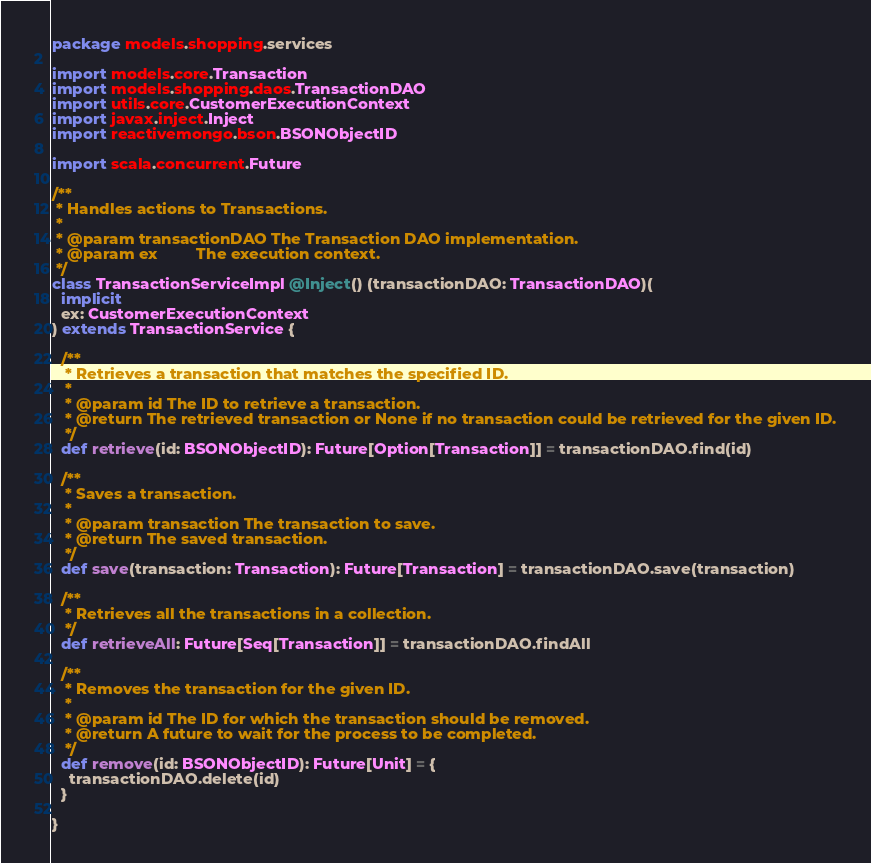<code> <loc_0><loc_0><loc_500><loc_500><_Scala_>package models.shopping.services

import models.core.Transaction
import models.shopping.daos.TransactionDAO
import utils.core.CustomerExecutionContext
import javax.inject.Inject
import reactivemongo.bson.BSONObjectID

import scala.concurrent.Future

/**
 * Handles actions to Transactions.
 *
 * @param transactionDAO The Transaction DAO implementation.
 * @param ex         The execution context.
 */
class TransactionServiceImpl @Inject() (transactionDAO: TransactionDAO)(
  implicit
  ex: CustomerExecutionContext
) extends TransactionService {

  /**
   * Retrieves a transaction that matches the specified ID.
   *
   * @param id The ID to retrieve a transaction.
   * @return The retrieved transaction or None if no transaction could be retrieved for the given ID.
   */
  def retrieve(id: BSONObjectID): Future[Option[Transaction]] = transactionDAO.find(id)

  /**
   * Saves a transaction.
   *
   * @param transaction The transaction to save.
   * @return The saved transaction.
   */
  def save(transaction: Transaction): Future[Transaction] = transactionDAO.save(transaction)

  /**
   * Retrieves all the transactions in a collection.
   */
  def retrieveAll: Future[Seq[Transaction]] = transactionDAO.findAll

  /**
   * Removes the transaction for the given ID.
   *
   * @param id The ID for which the transaction should be removed.
   * @return A future to wait for the process to be completed.
   */
  def remove(id: BSONObjectID): Future[Unit] = {
    transactionDAO.delete(id)
  }

}
</code> 